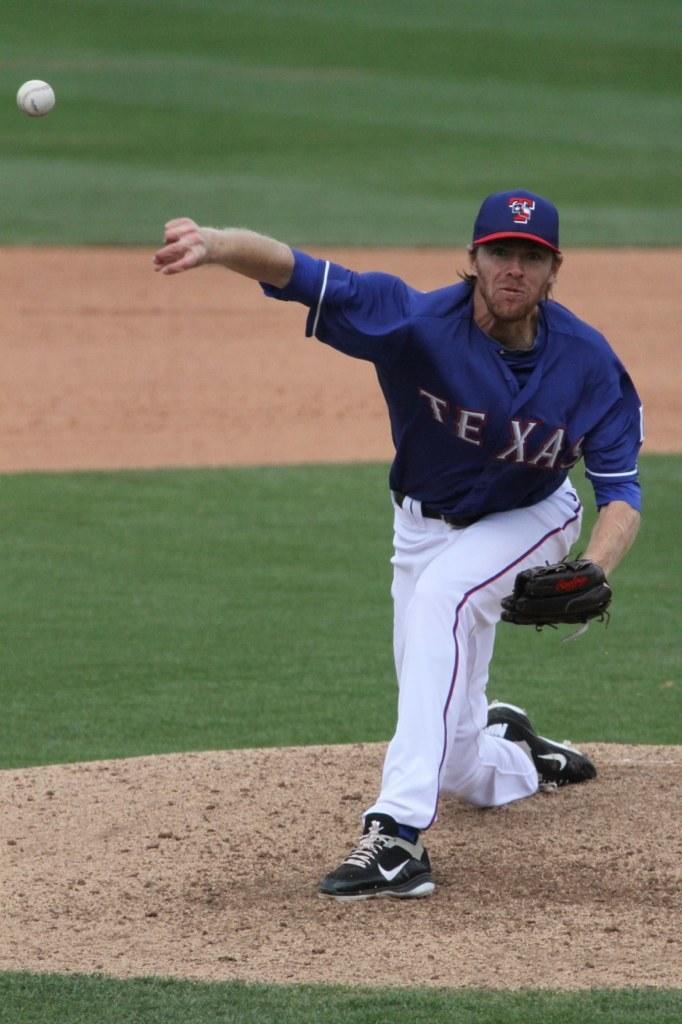What color letters is shown on jersey?
Provide a short and direct response. White. 